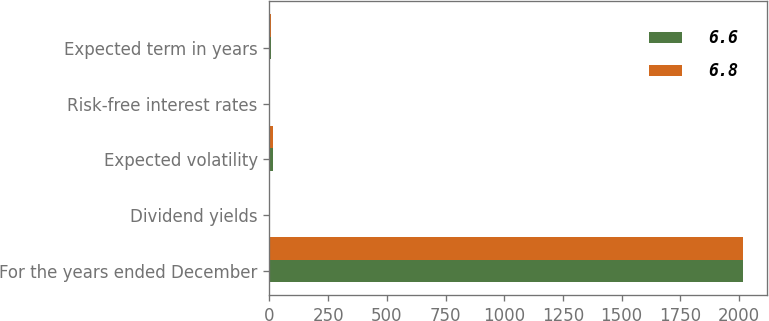Convert chart to OTSL. <chart><loc_0><loc_0><loc_500><loc_500><stacked_bar_chart><ecel><fcel>For the years ended December<fcel>Dividend yields<fcel>Expected volatility<fcel>Risk-free interest rates<fcel>Expected term in years<nl><fcel>6.6<fcel>2018<fcel>2.4<fcel>16.6<fcel>2.8<fcel>6.6<nl><fcel>6.8<fcel>2017<fcel>2.4<fcel>17.2<fcel>2.2<fcel>6.8<nl></chart> 